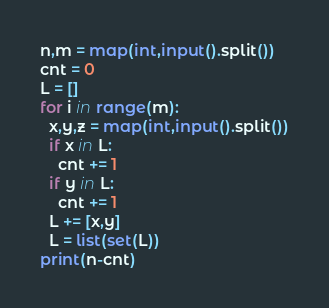<code> <loc_0><loc_0><loc_500><loc_500><_Python_>n,m = map(int,input().split())
cnt = 0
L = []
for i in range(m):
  x,y,z = map(int,input().split())
  if x in L:
    cnt += 1
  if y in L:
    cnt += 1
  L += [x,y]
  L = list(set(L))
print(n-cnt) 
</code> 